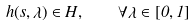Convert formula to latex. <formula><loc_0><loc_0><loc_500><loc_500>h ( s , \lambda ) \in H , \quad \forall \lambda \in [ 0 , 1 ]</formula> 